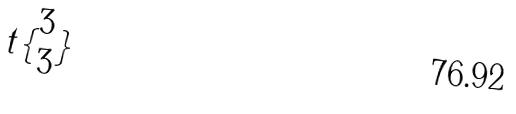Convert formula to latex. <formula><loc_0><loc_0><loc_500><loc_500>t \{ \begin{matrix} 3 \\ 3 \end{matrix} \}</formula> 